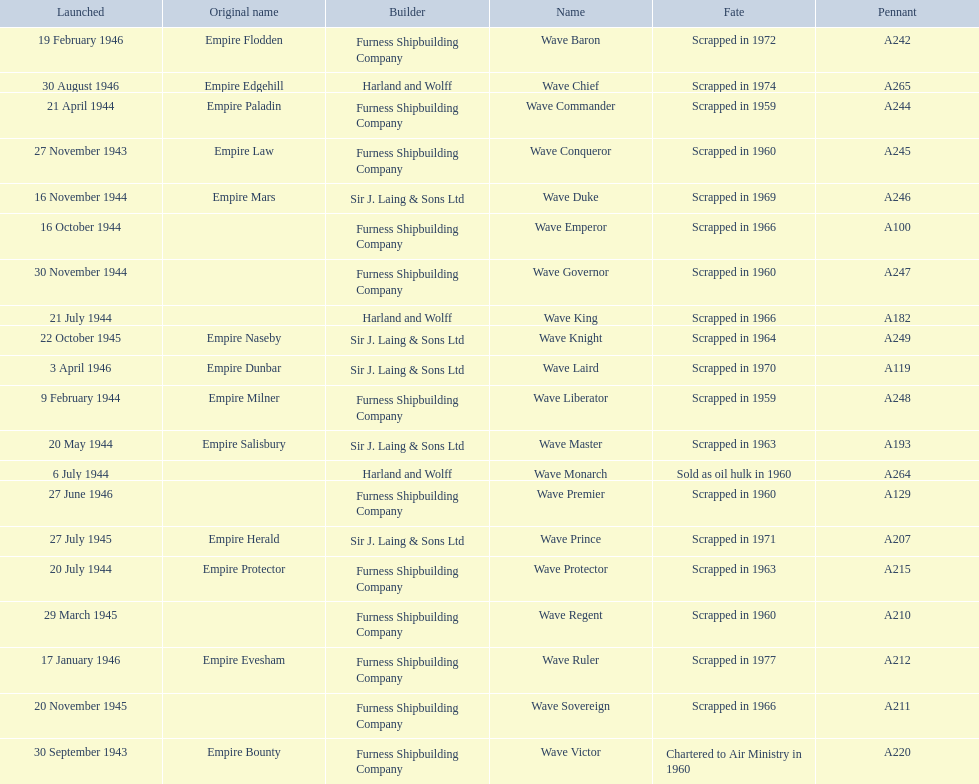What is the name of the last ship that was scrapped? Wave Ruler. 